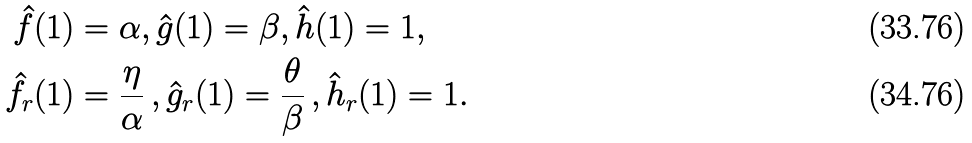<formula> <loc_0><loc_0><loc_500><loc_500>\hat { f } ( 1 ) & = \alpha , \hat { g } ( 1 ) = \beta , \hat { h } ( 1 ) = 1 , \\ \hat { f } _ { r } ( 1 ) & = \frac { \eta } { \alpha } \, , \hat { g } _ { r } ( 1 ) = \frac { \theta } { \beta } \, , \hat { h } _ { r } ( 1 ) = 1 .</formula> 